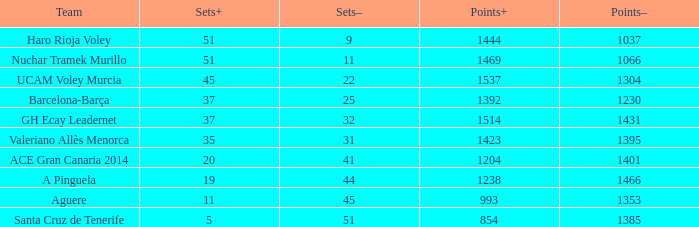When the sets- number was over 31, what was the highest sets+ value for valeriano allès menorca? None. Can you give me this table as a dict? {'header': ['Team', 'Sets+', 'Sets–', 'Points+', 'Points–'], 'rows': [['Haro Rioja Voley', '51', '9', '1444', '1037'], ['Nuchar Tramek Murillo', '51', '11', '1469', '1066'], ['UCAM Voley Murcia', '45', '22', '1537', '1304'], ['Barcelona-Barça', '37', '25', '1392', '1230'], ['GH Ecay Leadernet', '37', '32', '1514', '1431'], ['Valeriano Allès Menorca', '35', '31', '1423', '1395'], ['ACE Gran Canaria 2014', '20', '41', '1204', '1401'], ['A Pinguela', '19', '44', '1238', '1466'], ['Aguere', '11', '45', '993', '1353'], ['Santa Cruz de Tenerife', '5', '51', '854', '1385']]} 